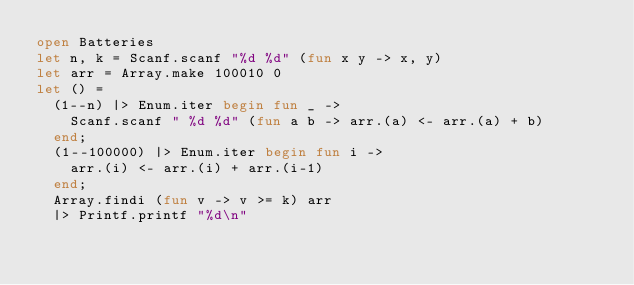Convert code to text. <code><loc_0><loc_0><loc_500><loc_500><_OCaml_>open Batteries
let n, k = Scanf.scanf "%d %d" (fun x y -> x, y)
let arr = Array.make 100010 0
let () =
  (1--n) |> Enum.iter begin fun _ ->
    Scanf.scanf " %d %d" (fun a b -> arr.(a) <- arr.(a) + b)
  end;
  (1--100000) |> Enum.iter begin fun i ->
    arr.(i) <- arr.(i) + arr.(i-1)
  end;
  Array.findi (fun v -> v >= k) arr
  |> Printf.printf "%d\n"
</code> 